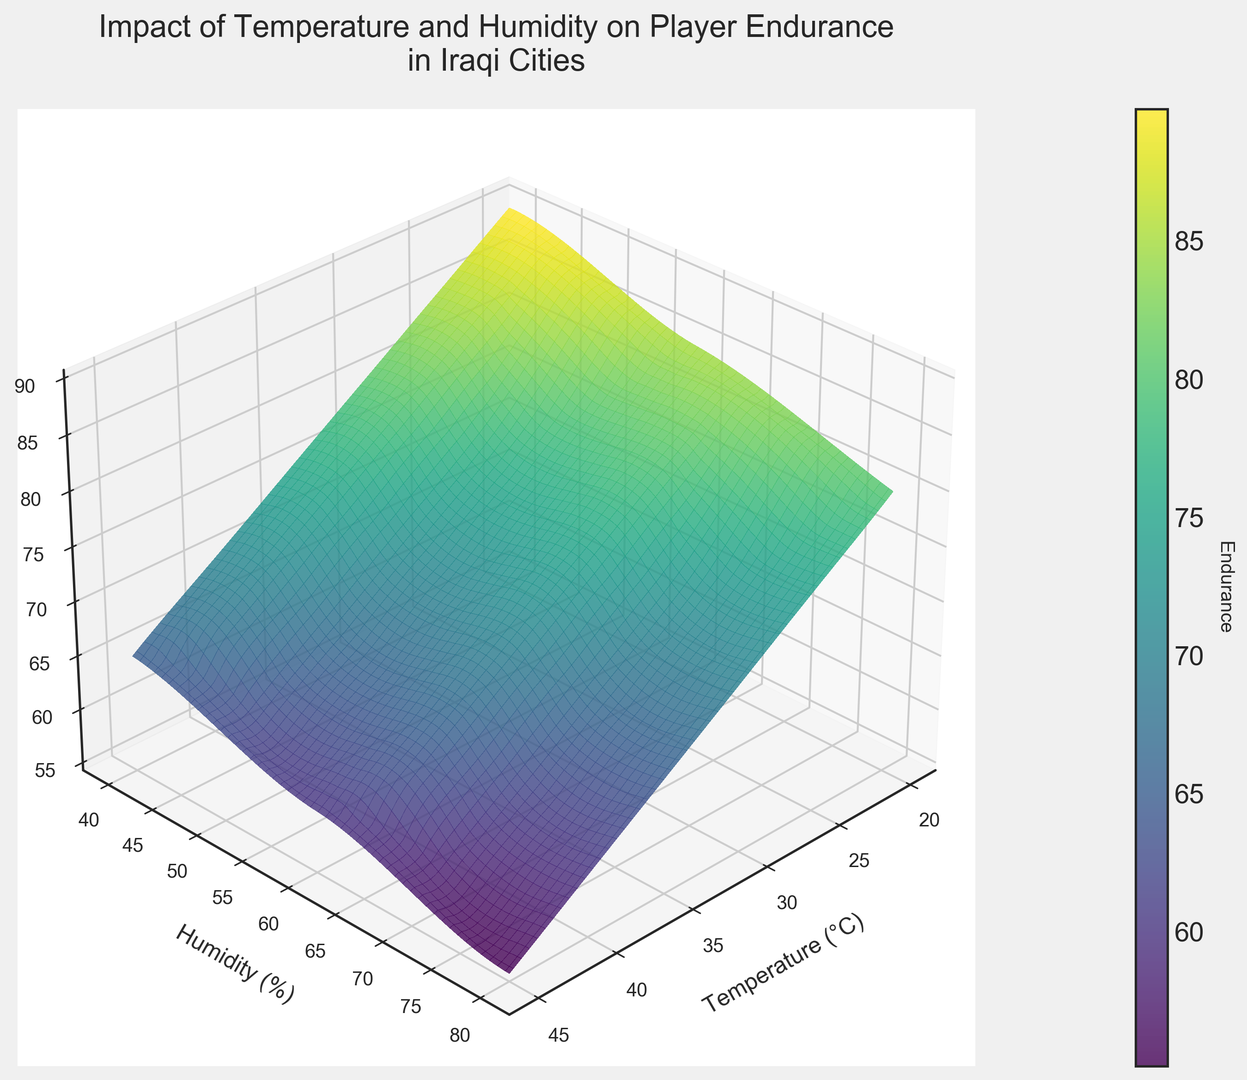What is the impact of increasing temperature on player endurance when humidity is constant at 60%? By observing the surface plot, follow the line where humidity is constant at 60%. As temperature increases from 20°C to 45°C, the endurance values decrease. This indicates higher temperatures reduce player endurance at a constant humidity level.
Answer: Endurance decreases What is the highest player endurance recorded and at what temperature and humidity does it occur? Check the highest point on the surface plot. The highest endurance value is 90, which occurs at 20°C and 40% humidity.
Answer: 90 at 20°C, 40% humidity How does player endurance at 35°C and 80% humidity compare to that at 25°C and 40% humidity? Look for the values of endurance at these specific temperature and humidity combinations. At 35°C and 80% humidity, endurance is 65, while at 25°C and 40% humidity, it is 85. Thus, player endurance is higher at the latter condition.
Answer: Higher at 25°C, 40% humidity Is there a sharp drop in player endurance as humidity increases from 40% to 80% at a temperature of 45°C? Trace the endurance values on the plot at 45°C as humidity moves from 40% to 80%. Endurance drops from 65 to 55, showing a noticeable decrease.
Answer: Yes, there is a sharp drop At which temperature and humidity do we see player endurance drop below 70? Examine the surface plot to find the threshold where endurance first falls below 70. This happens at various points, for instance, at 30°C and 80% humidity or 35°C and 60% humidity.
Answer: Multiple points, e.g., 30°C, 80% humidity or 35°C, 60% humidity What is the average endurance at 40°C across all humidity levels? Locate the endurance values at 40°C for all humidity levels (40%, 60%, 80%): 70, 65, 60. Calculate the average: (70 + 65 + 60)/3 = 65.
Answer: 65 How does the shape of the surface plot suggest a combined effect of temperature and humidity on player endurance? Observe the curvature and slopes of the surface. The plot clearly shows a declining plane indicating that both higher temperature and higher humidity negatively impact player endurance.
Answer: Combined negative effect What pattern do you see in player endurance at 20°C compared to 45°C as humidity increases? Follow the endurance values at 20°C and 45°C. At 20°C, endurance slightly decreases from 90 to 80 as humidity rises from 40% to 80%. At 45°C, endurance decreases more sharply from 65 to 55. Thus, higher temperatures cause a steeper decline.
Answer: Steeper decline at 45°C For a balanced approach to training, which temperature and humidity levels should players prefer based on the plot? Identify where the endurance values are highest on the plot, indicating optimal training conditions. Preferred conditions are generally cooler and less humid, such as 20°C to 25°C with around 40-60% humidity.
Answer: 20°C to 25°C, 40-60% humidity 